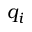<formula> <loc_0><loc_0><loc_500><loc_500>q _ { i }</formula> 